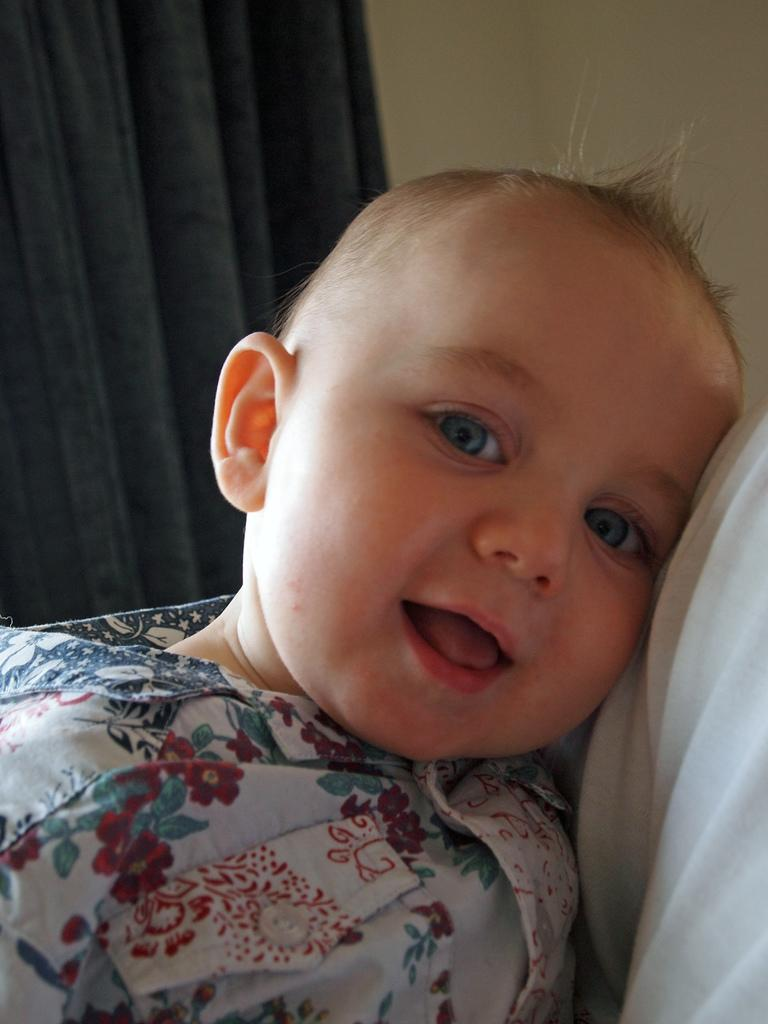What is the main subject of the picture? The main subject of the picture is a baby. What can be seen behind the baby? There is a wall behind the baby. Are there any other elements in the image besides the baby and the wall? Yes, there is a curtain present in the image. What type of ray is swimming in the background of the image? There is no ray present in the image; it features a baby and a wall. Who is the writer of the book that the baby is holding in the image? The image does not show the baby holding a book, nor is there any writer mentioned. 